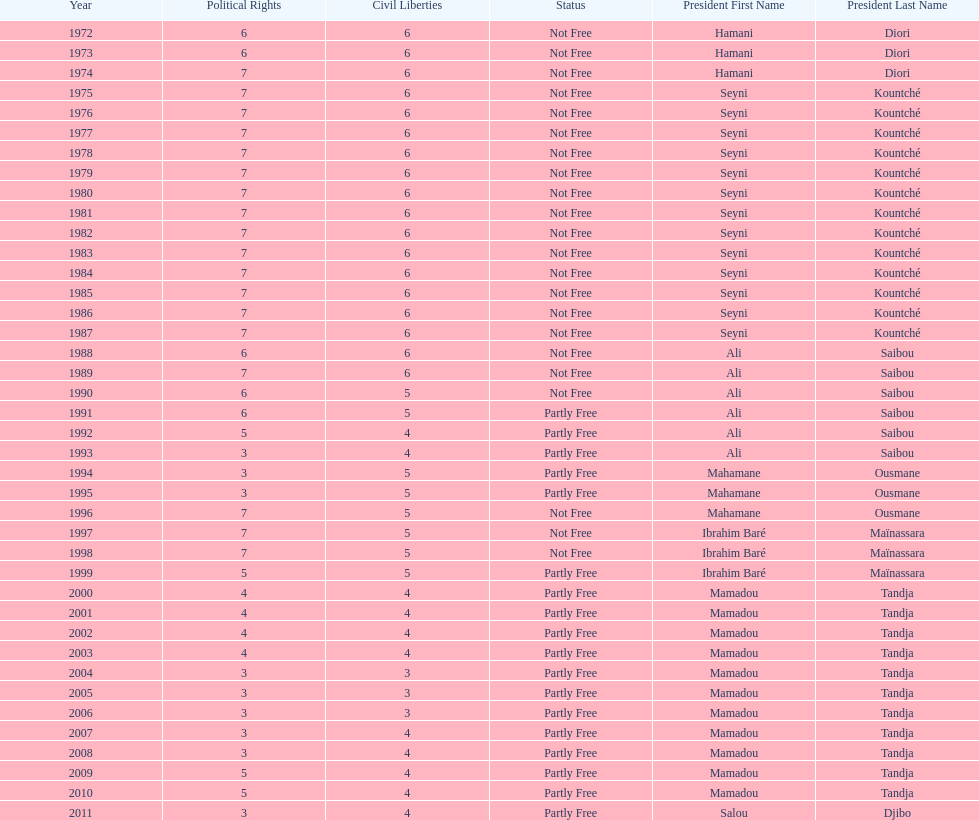Who is the next president listed after hamani diori in the year 1974? Seyni Kountché. 